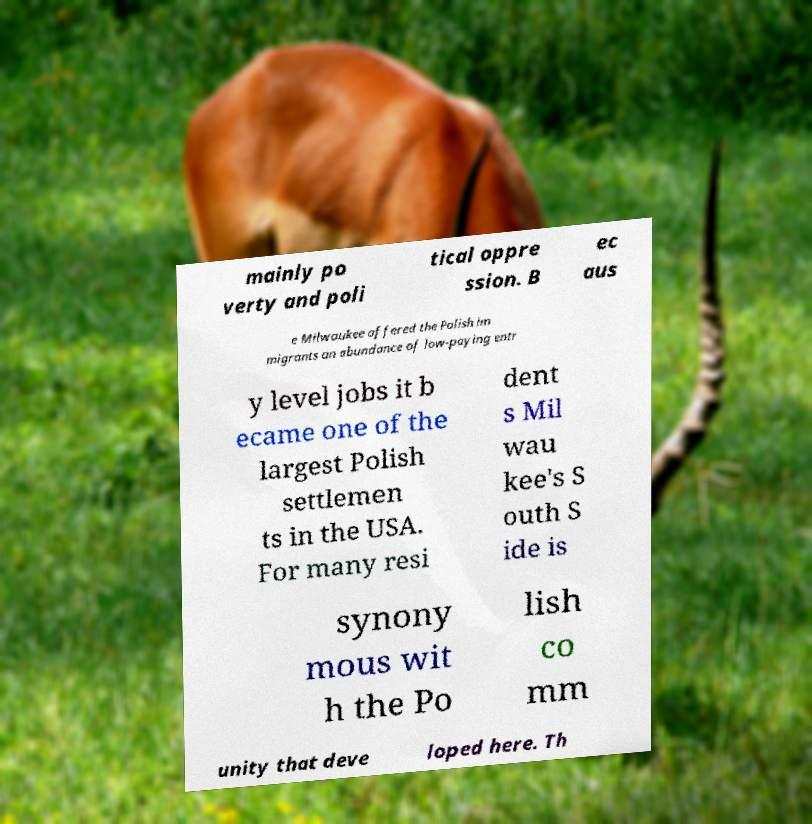Can you read and provide the text displayed in the image?This photo seems to have some interesting text. Can you extract and type it out for me? mainly po verty and poli tical oppre ssion. B ec aus e Milwaukee offered the Polish im migrants an abundance of low-paying entr y level jobs it b ecame one of the largest Polish settlemen ts in the USA. For many resi dent s Mil wau kee's S outh S ide is synony mous wit h the Po lish co mm unity that deve loped here. Th 